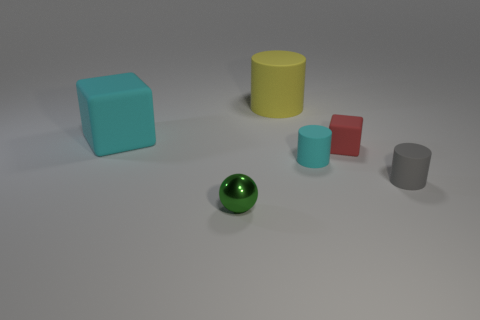Add 2 large objects. How many objects exist? 8 Subtract all balls. How many objects are left? 5 Subtract 0 red spheres. How many objects are left? 6 Subtract all cyan things. Subtract all gray objects. How many objects are left? 3 Add 2 cubes. How many cubes are left? 4 Add 5 large blue cylinders. How many large blue cylinders exist? 5 